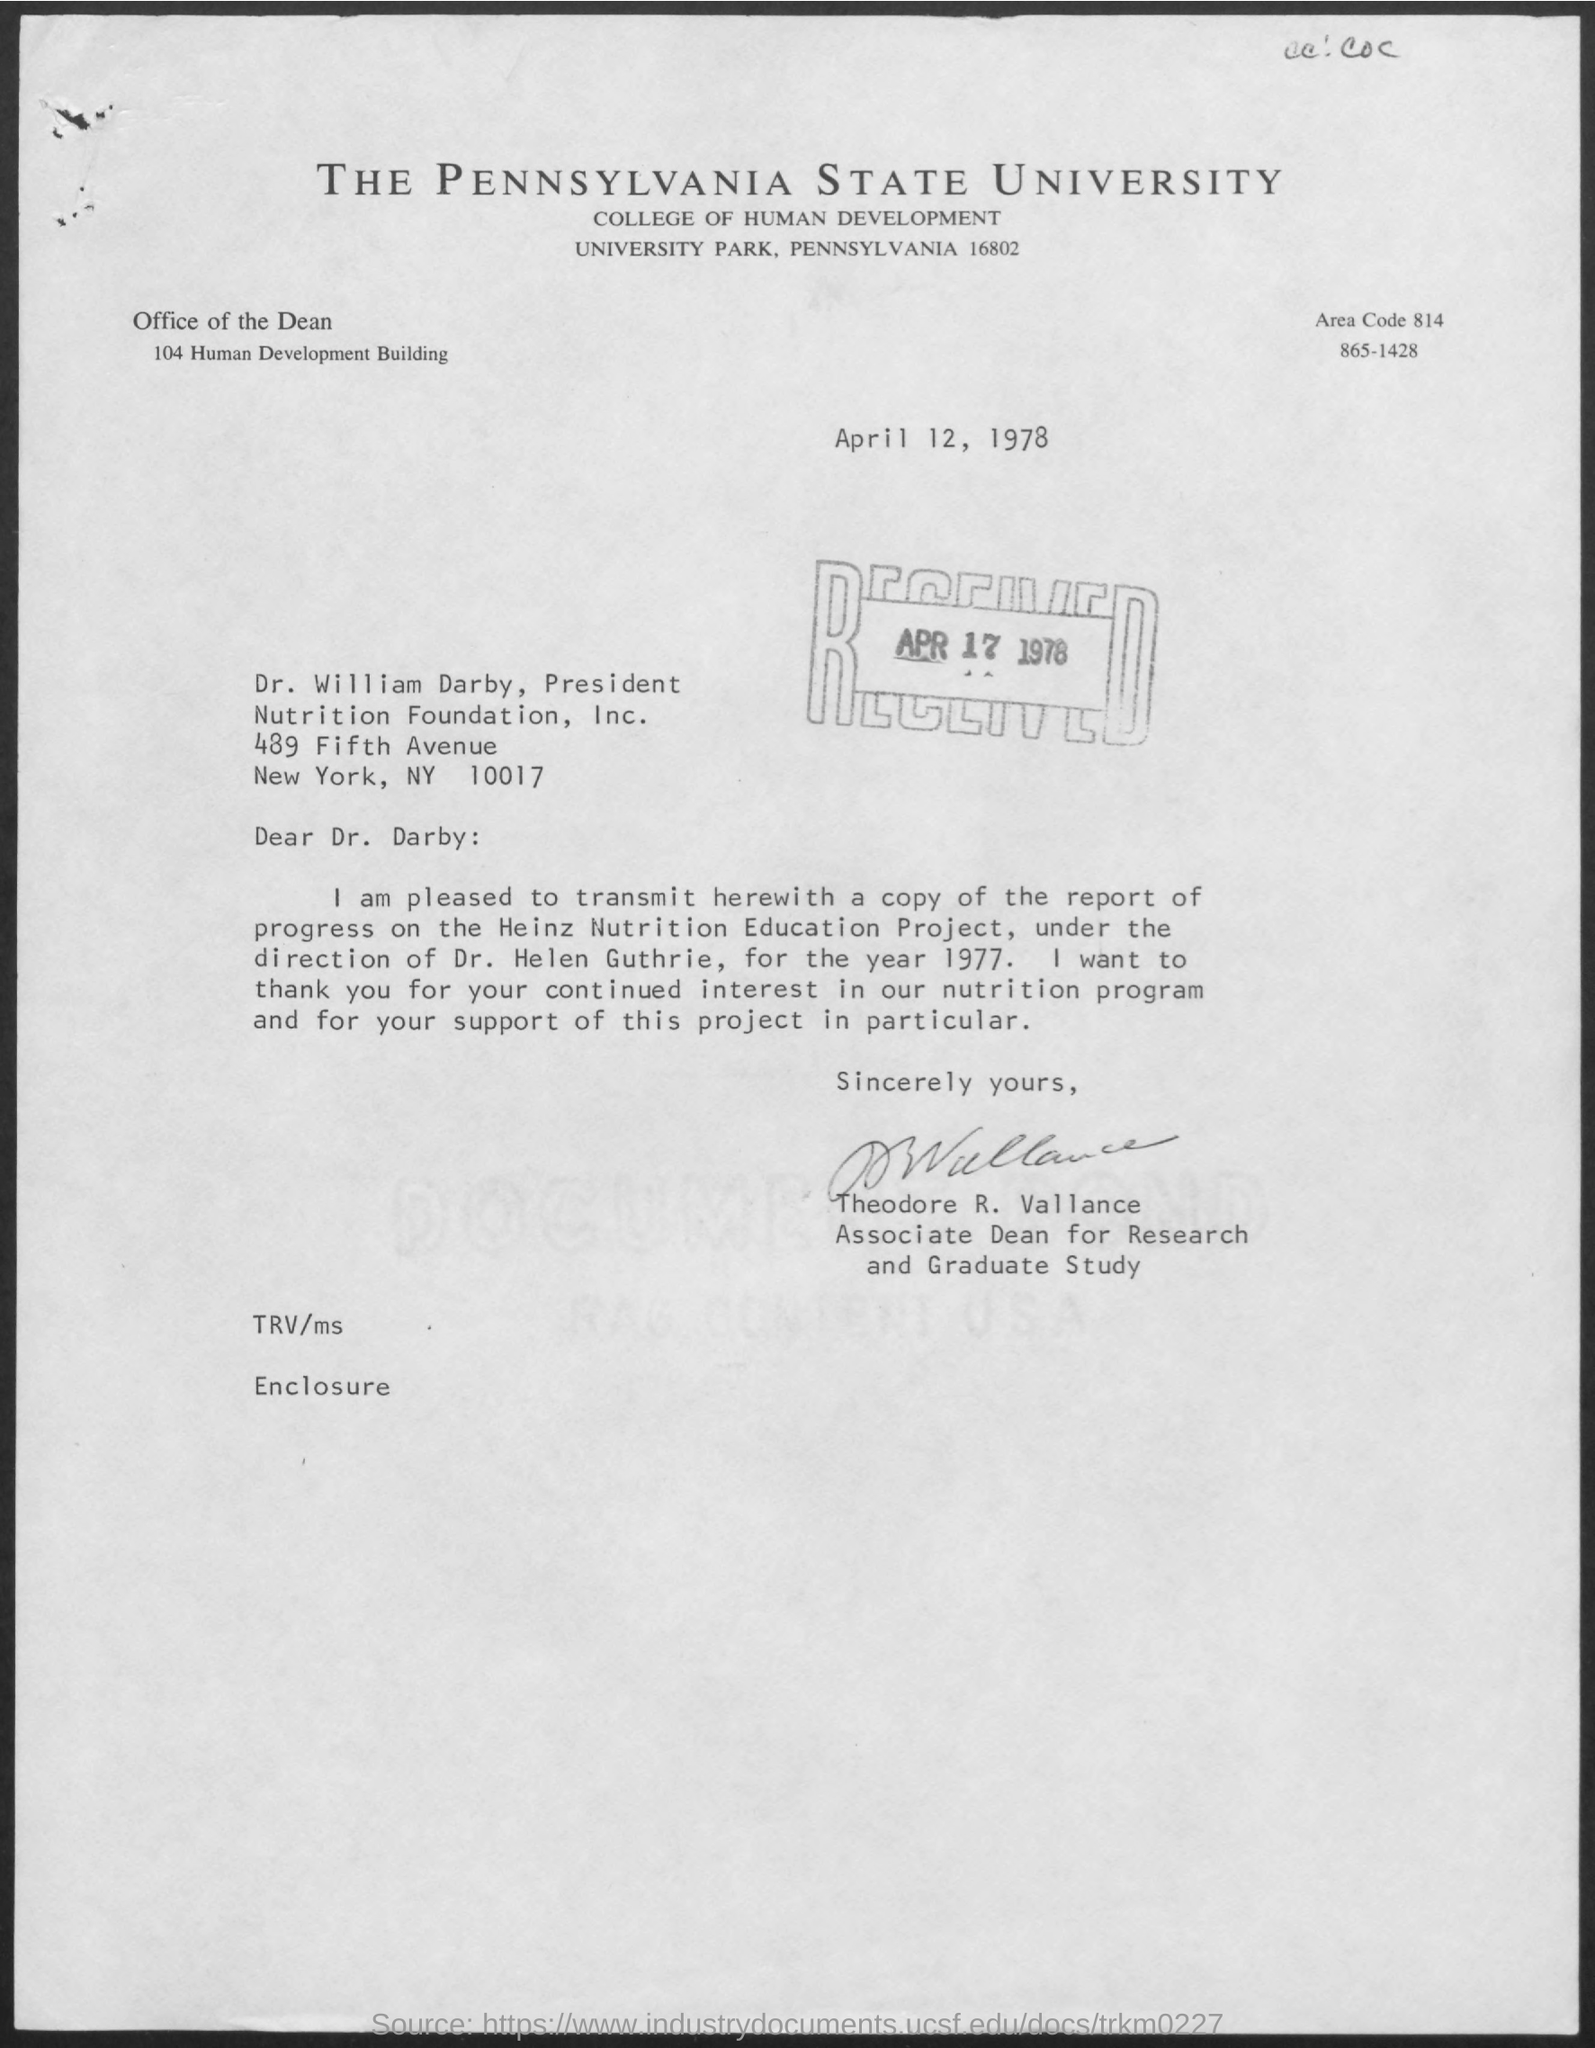Who is this letter from?
Offer a terse response. Theodore R. Vallance. 